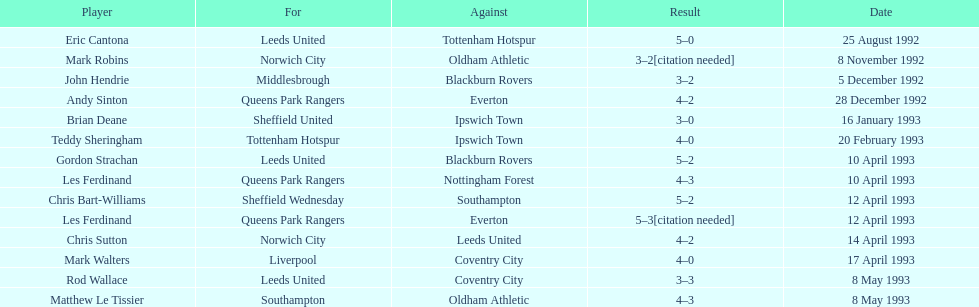Southampton had a match on may 8th, 1993 - who were they up against? Oldham Athletic. 